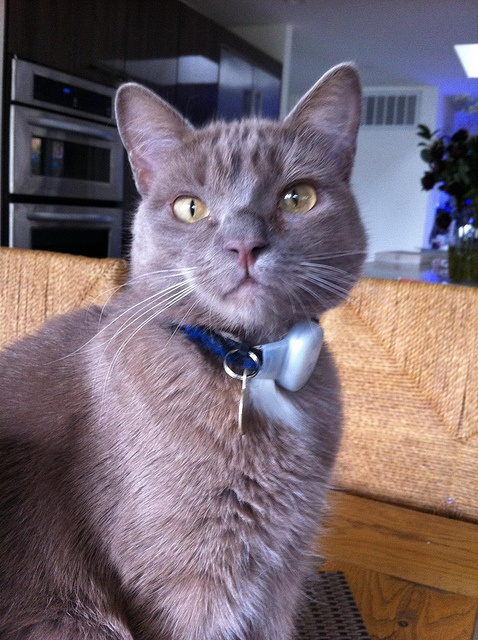Describe the objects in this image and their specific colors. I can see cat in gray, darkgray, and black tones, oven in gray and black tones, and potted plant in gray, black, and navy tones in this image. 